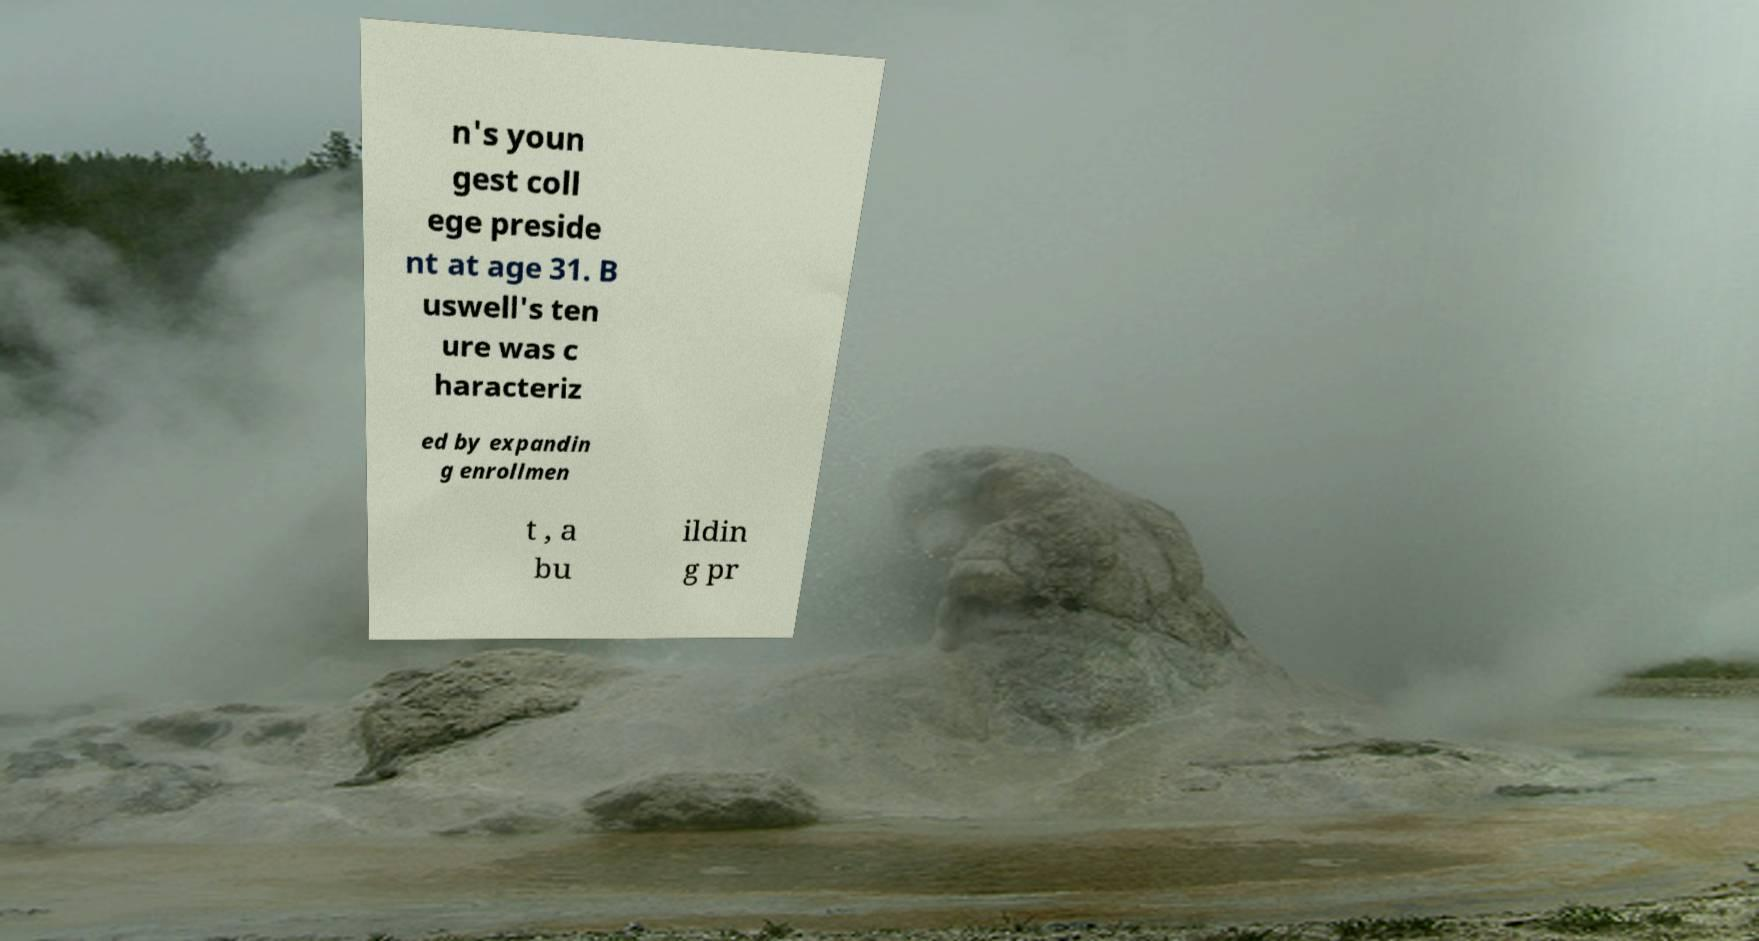There's text embedded in this image that I need extracted. Can you transcribe it verbatim? n's youn gest coll ege preside nt at age 31. B uswell's ten ure was c haracteriz ed by expandin g enrollmen t , a bu ildin g pr 